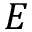<formula> <loc_0><loc_0><loc_500><loc_500>E</formula> 